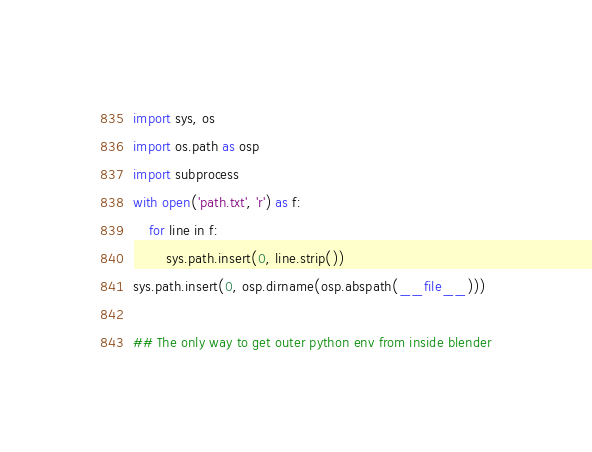<code> <loc_0><loc_0><loc_500><loc_500><_Python_>import sys, os
import os.path as osp
import subprocess
with open('path.txt', 'r') as f:
    for line in f:
        sys.path.insert(0, line.strip())
sys.path.insert(0, osp.dirname(osp.abspath(__file__)))

## The only way to get outer python env from inside blender</code> 